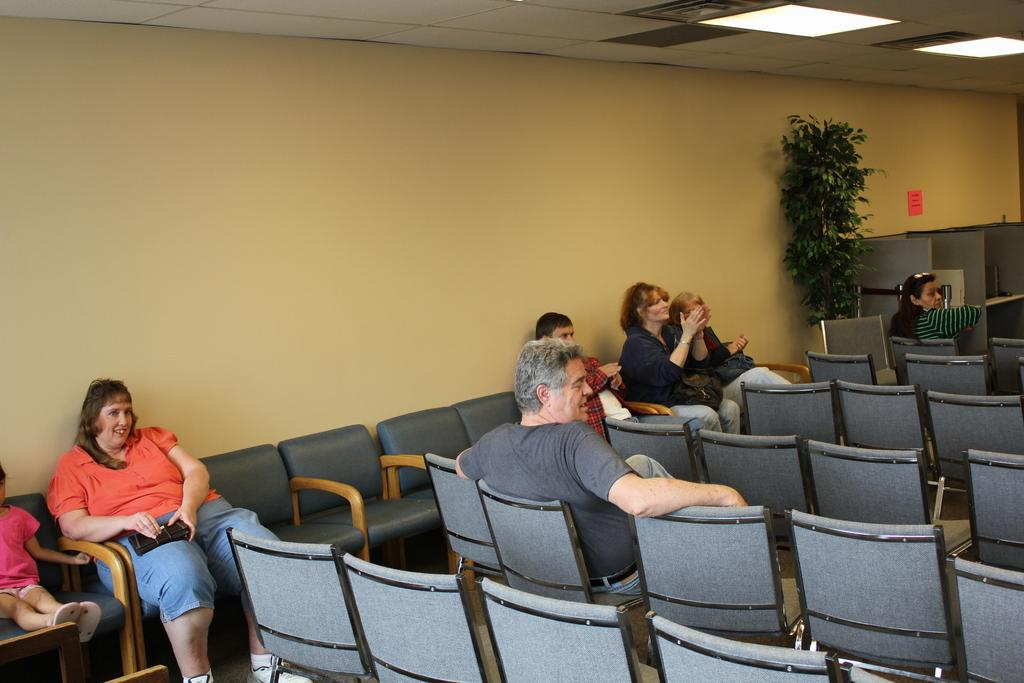What type of furniture can be seen in the room? There are chairs in the room. How many people are sitting on the chairs? There are seven people sitting on the chairs. What kind of plant is present in the room? There is a plant in the room. What type of storage or display feature is in the room? There is a shelf in the room. What type of authority figure is present in the room? There is no authority figure mentioned in the provided facts, so we cannot determine if one is present in the room. What kind of butter can be seen on the shelf in the room? There is no mention of butter in the provided facts, so we cannot determine if it is present in the room. 